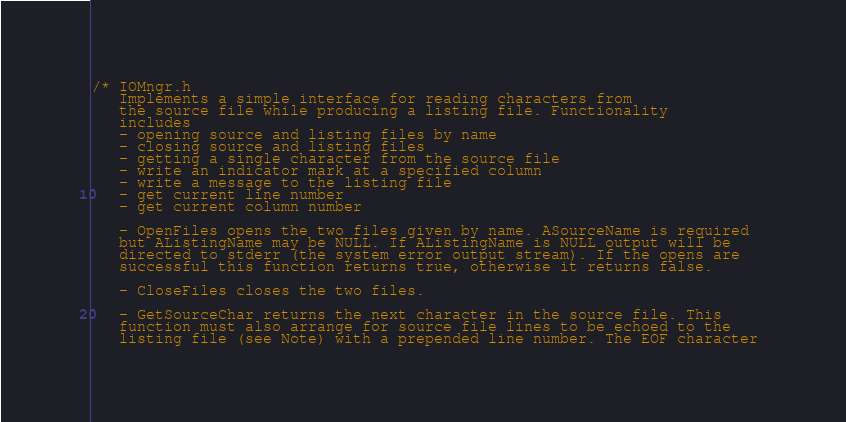Convert code to text. <code><loc_0><loc_0><loc_500><loc_500><_C_>/* IOMngr.h
   Implements a simple interface for reading characters from
   the source file while producing a listing file. Functionality
   includes
   - opening source and listing files by name
   - closing source and listing files
   - getting a single character from the source file
   - write an indicator mark at a specified column
   - write a message to the listing file
   - get current line number
   - get current column number
   
   - OpenFiles opens the two files given by name. ASourceName is required 
   but AListingName may be NULL. If AListingName is NULL output will be 
   directed to stderr (the system error output stream). If the opens are
   successful this function returns true, otherwise it returns false. 
   
   - CloseFiles closes the two files.
   
   - GetSourceChar returns the next character in the source file. This
   function must also arrange for source file lines to be echoed to the 
   listing file (see Note) with a prepended line number. The EOF character </code> 